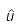<formula> <loc_0><loc_0><loc_500><loc_500>\hat { u }</formula> 